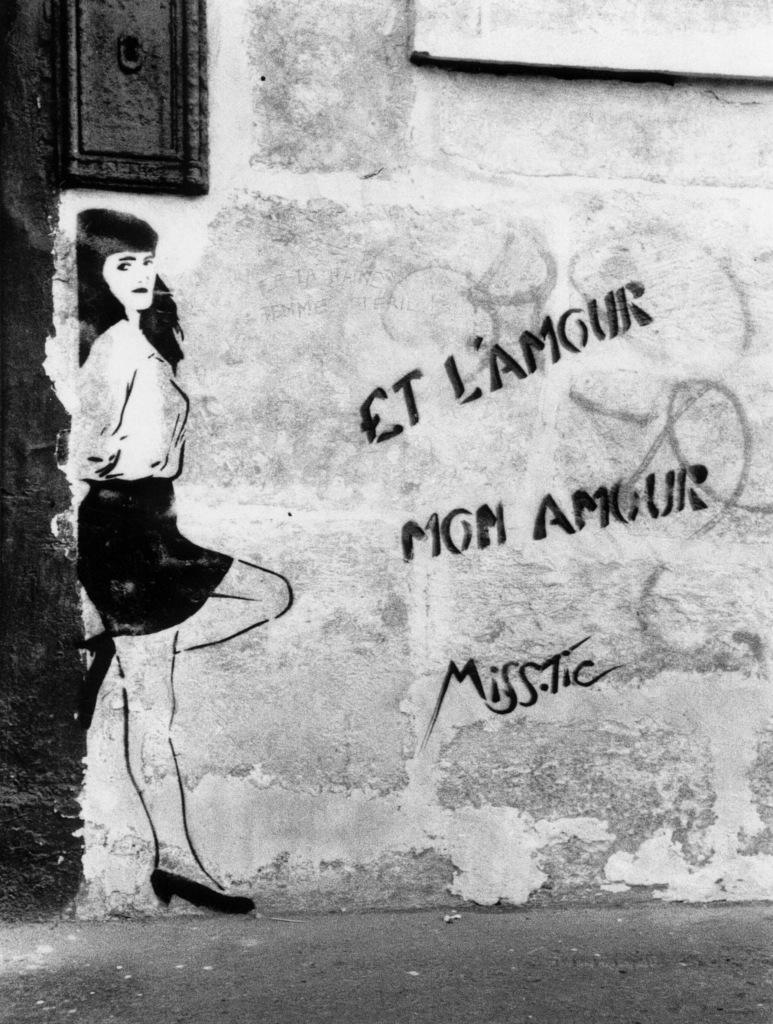What is located in the foreground of the image? There is a road in the foreground of the image. What can be seen on the wall in the image? There is a painting of a woman on a wall in the image. What additional information is provided with the painting? There is text associated with the painting in the image. How many fingers does the scarecrow have in the image? There is no scarecrow present in the image, so it is not possible to determine the number of fingers on a scarecrow. 